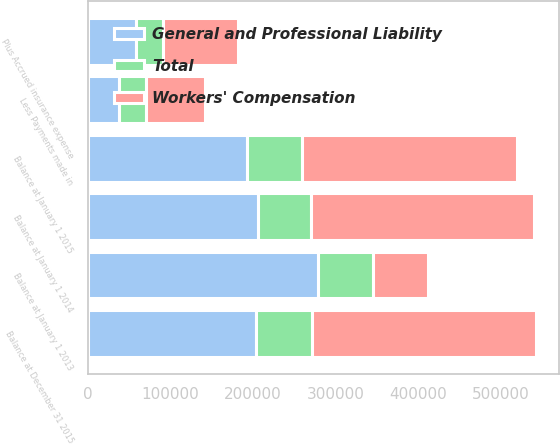Convert chart. <chart><loc_0><loc_0><loc_500><loc_500><stacked_bar_chart><ecel><fcel>Balance at January 1 2013<fcel>Plus Accrued insurance expense<fcel>Less Payments made in<fcel>Balance at January 1 2014<fcel>Balance at January 1 2015<fcel>Balance at December 31 2015<nl><fcel>General and Professional Liability<fcel>278599<fcel>58460<fcel>37127<fcel>206290<fcel>192904<fcel>203973<nl><fcel>Total<fcel>65954<fcel>32435<fcel>33517<fcel>63798<fcel>66814<fcel>67503<nl><fcel>Workers' Compensation<fcel>67158.5<fcel>90895<fcel>70644<fcel>270088<fcel>259718<fcel>271476<nl></chart> 